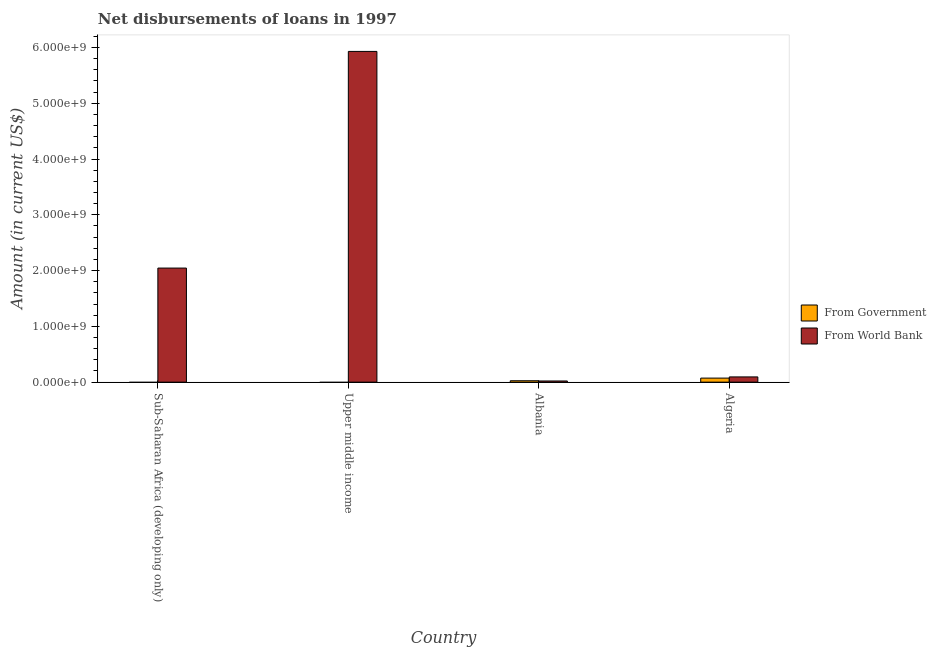Are the number of bars per tick equal to the number of legend labels?
Provide a succinct answer. No. Are the number of bars on each tick of the X-axis equal?
Provide a short and direct response. No. How many bars are there on the 4th tick from the left?
Provide a succinct answer. 2. How many bars are there on the 2nd tick from the right?
Give a very brief answer. 2. What is the label of the 4th group of bars from the left?
Make the answer very short. Algeria. What is the net disbursements of loan from world bank in Albania?
Your answer should be very brief. 2.10e+07. Across all countries, what is the maximum net disbursements of loan from government?
Keep it short and to the point. 7.26e+07. Across all countries, what is the minimum net disbursements of loan from world bank?
Offer a very short reply. 2.10e+07. In which country was the net disbursements of loan from government maximum?
Your response must be concise. Algeria. What is the total net disbursements of loan from world bank in the graph?
Ensure brevity in your answer.  8.09e+09. What is the difference between the net disbursements of loan from world bank in Algeria and that in Upper middle income?
Ensure brevity in your answer.  -5.84e+09. What is the difference between the net disbursements of loan from government in Sub-Saharan Africa (developing only) and the net disbursements of loan from world bank in Albania?
Ensure brevity in your answer.  -2.10e+07. What is the average net disbursements of loan from government per country?
Your response must be concise. 2.44e+07. What is the difference between the net disbursements of loan from government and net disbursements of loan from world bank in Algeria?
Your answer should be compact. -2.14e+07. In how many countries, is the net disbursements of loan from government greater than 1800000000 US$?
Provide a succinct answer. 0. What is the ratio of the net disbursements of loan from world bank in Algeria to that in Upper middle income?
Your answer should be very brief. 0.02. What is the difference between the highest and the second highest net disbursements of loan from world bank?
Offer a terse response. 3.88e+09. What is the difference between the highest and the lowest net disbursements of loan from world bank?
Your response must be concise. 5.91e+09. What is the difference between two consecutive major ticks on the Y-axis?
Offer a terse response. 1.00e+09. Are the values on the major ticks of Y-axis written in scientific E-notation?
Your answer should be very brief. Yes. Does the graph contain any zero values?
Your answer should be very brief. Yes. Does the graph contain grids?
Ensure brevity in your answer.  No. What is the title of the graph?
Give a very brief answer. Net disbursements of loans in 1997. What is the label or title of the X-axis?
Your answer should be very brief. Country. What is the Amount (in current US$) in From World Bank in Sub-Saharan Africa (developing only)?
Keep it short and to the point. 2.05e+09. What is the Amount (in current US$) in From Government in Upper middle income?
Keep it short and to the point. 0. What is the Amount (in current US$) of From World Bank in Upper middle income?
Give a very brief answer. 5.93e+09. What is the Amount (in current US$) of From Government in Albania?
Your answer should be compact. 2.52e+07. What is the Amount (in current US$) of From World Bank in Albania?
Your answer should be compact. 2.10e+07. What is the Amount (in current US$) in From Government in Algeria?
Provide a succinct answer. 7.26e+07. What is the Amount (in current US$) in From World Bank in Algeria?
Your response must be concise. 9.40e+07. Across all countries, what is the maximum Amount (in current US$) in From Government?
Make the answer very short. 7.26e+07. Across all countries, what is the maximum Amount (in current US$) of From World Bank?
Your answer should be compact. 5.93e+09. Across all countries, what is the minimum Amount (in current US$) of From World Bank?
Your response must be concise. 2.10e+07. What is the total Amount (in current US$) in From Government in the graph?
Provide a short and direct response. 9.78e+07. What is the total Amount (in current US$) of From World Bank in the graph?
Give a very brief answer. 8.09e+09. What is the difference between the Amount (in current US$) of From World Bank in Sub-Saharan Africa (developing only) and that in Upper middle income?
Keep it short and to the point. -3.88e+09. What is the difference between the Amount (in current US$) of From World Bank in Sub-Saharan Africa (developing only) and that in Albania?
Give a very brief answer. 2.02e+09. What is the difference between the Amount (in current US$) in From World Bank in Sub-Saharan Africa (developing only) and that in Algeria?
Make the answer very short. 1.95e+09. What is the difference between the Amount (in current US$) of From World Bank in Upper middle income and that in Albania?
Provide a short and direct response. 5.91e+09. What is the difference between the Amount (in current US$) of From World Bank in Upper middle income and that in Algeria?
Your response must be concise. 5.84e+09. What is the difference between the Amount (in current US$) of From Government in Albania and that in Algeria?
Give a very brief answer. -4.74e+07. What is the difference between the Amount (in current US$) of From World Bank in Albania and that in Algeria?
Offer a very short reply. -7.29e+07. What is the difference between the Amount (in current US$) of From Government in Albania and the Amount (in current US$) of From World Bank in Algeria?
Provide a short and direct response. -6.88e+07. What is the average Amount (in current US$) of From Government per country?
Make the answer very short. 2.44e+07. What is the average Amount (in current US$) in From World Bank per country?
Keep it short and to the point. 2.02e+09. What is the difference between the Amount (in current US$) in From Government and Amount (in current US$) in From World Bank in Albania?
Keep it short and to the point. 4.18e+06. What is the difference between the Amount (in current US$) in From Government and Amount (in current US$) in From World Bank in Algeria?
Make the answer very short. -2.14e+07. What is the ratio of the Amount (in current US$) in From World Bank in Sub-Saharan Africa (developing only) to that in Upper middle income?
Your answer should be compact. 0.34. What is the ratio of the Amount (in current US$) of From World Bank in Sub-Saharan Africa (developing only) to that in Albania?
Offer a very short reply. 97.32. What is the ratio of the Amount (in current US$) of From World Bank in Sub-Saharan Africa (developing only) to that in Algeria?
Offer a very short reply. 21.77. What is the ratio of the Amount (in current US$) in From World Bank in Upper middle income to that in Albania?
Make the answer very short. 282.14. What is the ratio of the Amount (in current US$) of From World Bank in Upper middle income to that in Algeria?
Provide a short and direct response. 63.11. What is the ratio of the Amount (in current US$) in From Government in Albania to that in Algeria?
Make the answer very short. 0.35. What is the ratio of the Amount (in current US$) of From World Bank in Albania to that in Algeria?
Provide a succinct answer. 0.22. What is the difference between the highest and the second highest Amount (in current US$) in From World Bank?
Give a very brief answer. 3.88e+09. What is the difference between the highest and the lowest Amount (in current US$) in From Government?
Offer a terse response. 7.26e+07. What is the difference between the highest and the lowest Amount (in current US$) in From World Bank?
Ensure brevity in your answer.  5.91e+09. 